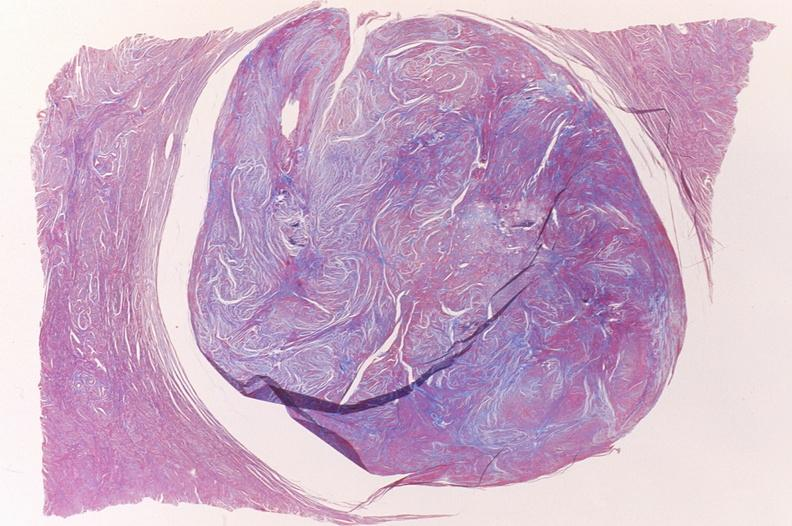what does this image show?
Answer the question using a single word or phrase. Leiomyoma 